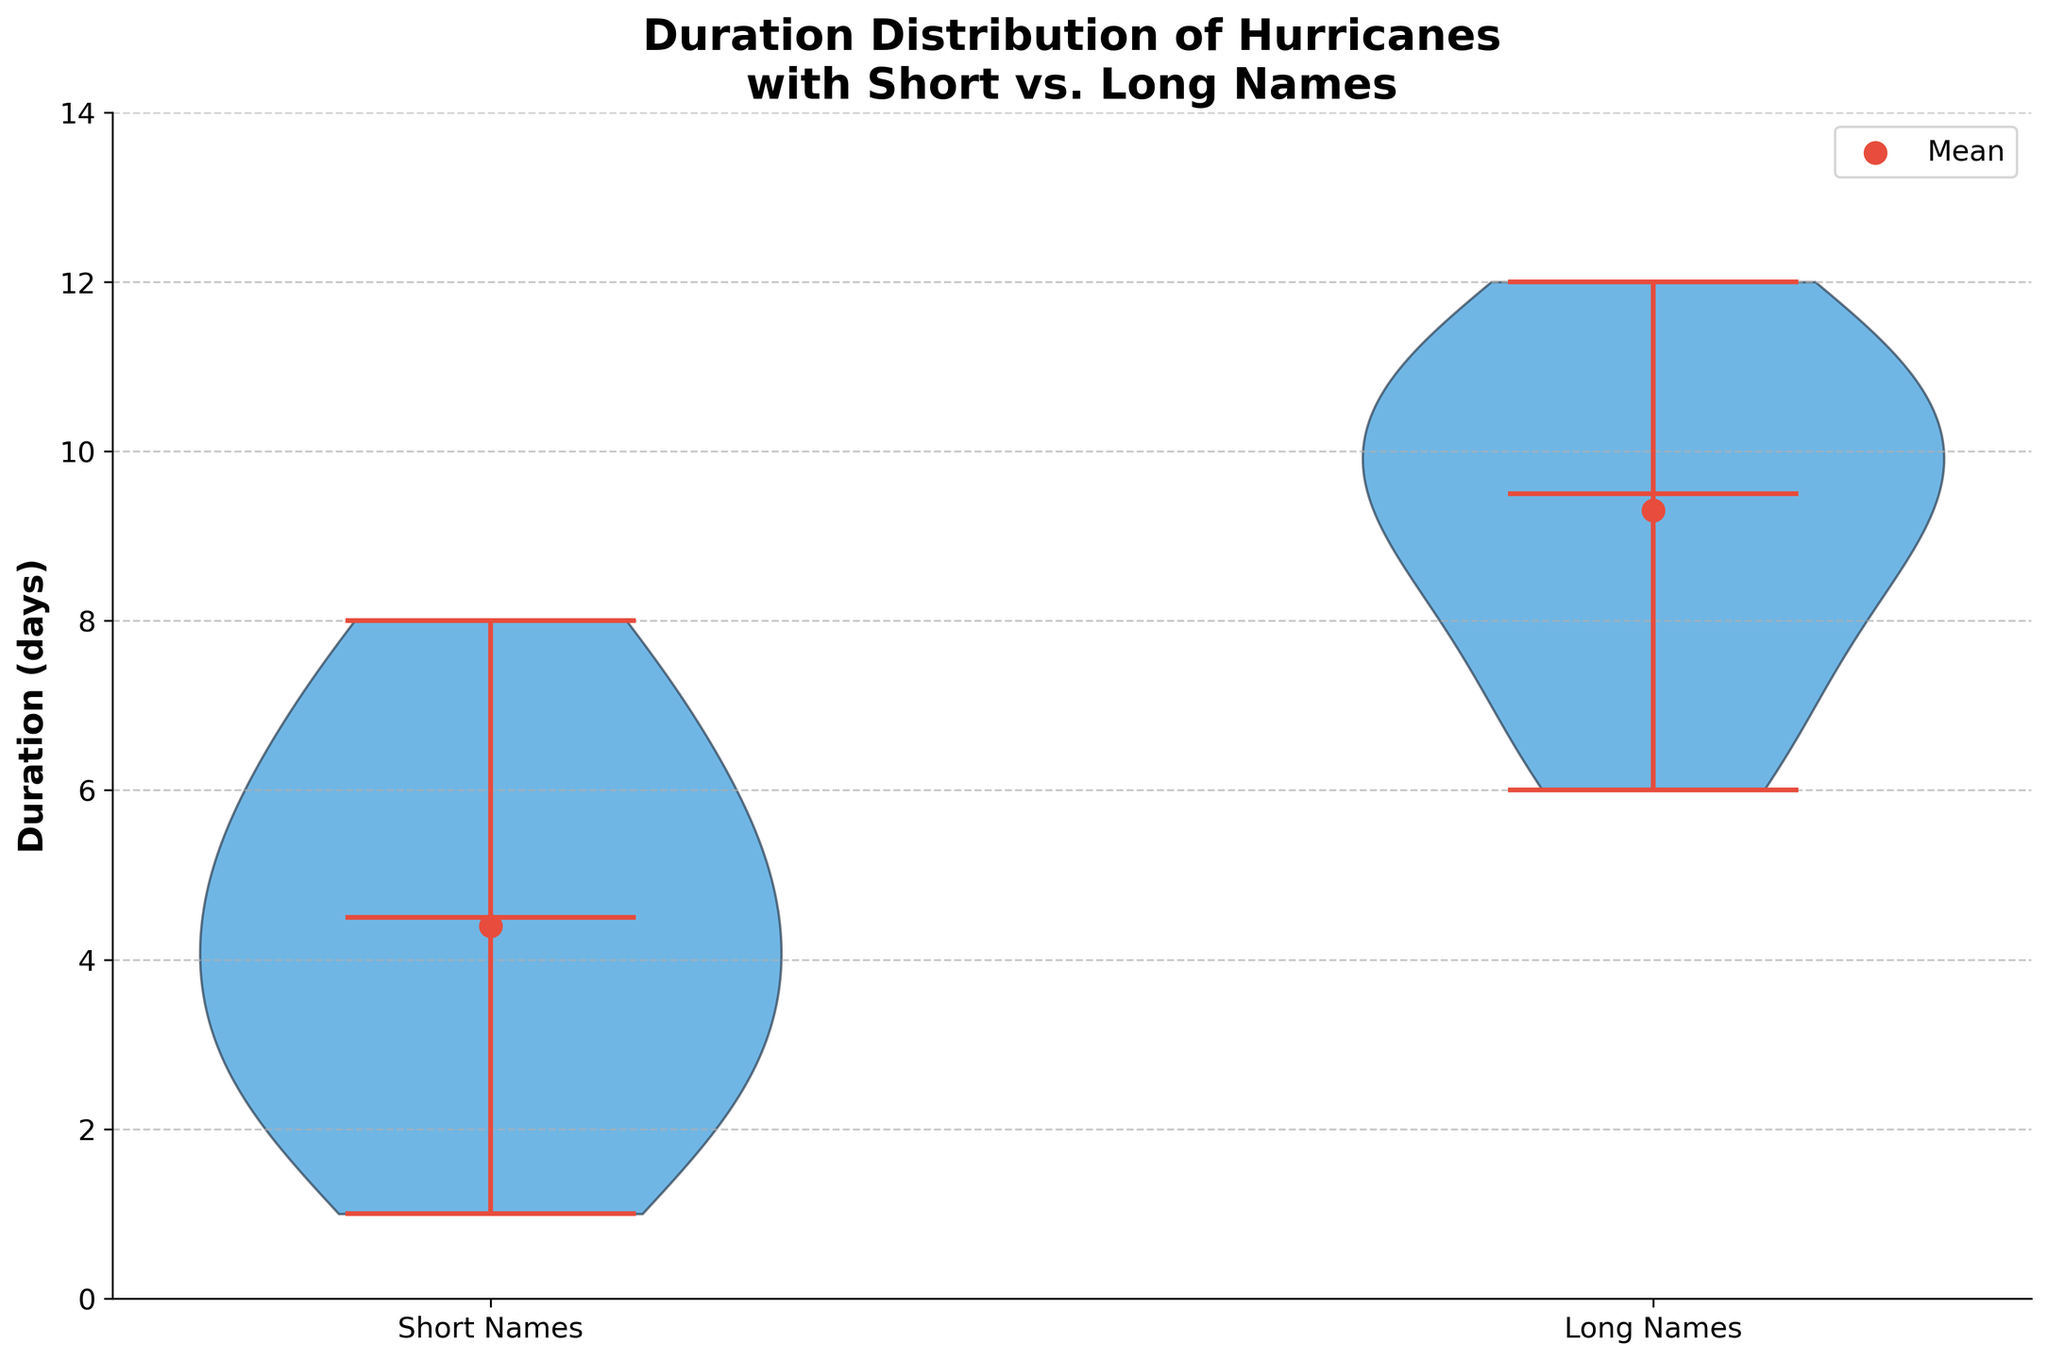What does the title of the violin plot indicate? The title "Duration Distribution of Hurricanes with Short vs. Long Names" indicates the plot is showing the distribution of hurricane durations categorized by the length of their names (short or long).
Answer: Duration Distribution of Hurricanes with Short vs. Long Names What category appears on the x-axis of the violin plot? The x-axis categories are "Short Names" and "Long Names," representing hurricanes with short and long names, respectively.
Answer: Short Names and Long Names What does the y-axis represent in this violin plot? The y-axis represents the duration of hurricanes in days.
Answer: Duration (days) Which category typically has longer durations, short or long-named hurricanes? Based on the plot, the category of long-named hurricanes typically has longer durations as indicated by higher median and spread.
Answer: Long-named hurricanes What is the median duration of hurricanes with short names? The median duration is marked by a line in the center of the violin plot for short names. It is around 4 days.
Answer: 4 days What is the median duration of hurricanes with long names? The median duration is marked by a line in the center of the violin plot for long names. It is around 9 days.
Answer: 9 days Which category has a wider distribution of hurricane durations? The long-named hurricanes have a wider distribution, as the spread of the long-named violin plot extends more broadly compared to the short-named violin plot.
Answer: Long-named hurricanes What are the mean durations for short and long-named hurricanes? The mean durations are indicated by red dots on the plot. The mean for short names is around 4.4 days, and for long names, it is around 9.3 days.
Answer: Short names: 4.4 days, Long names: 9.3 days Are there any outliers visible in the duration distribution of hurricanes with short names? No significant outliers are evident in the distribution of short-named hurricanes as the shapes are relatively smooth.
Answer: No Between short and long-named hurricanes, which group shows a higher maximum duration? The long-named hurricanes show a higher maximum duration, indicated by the upper extent of the violin plot, reaching up to about 12 days.
Answer: Long-named hurricanes 